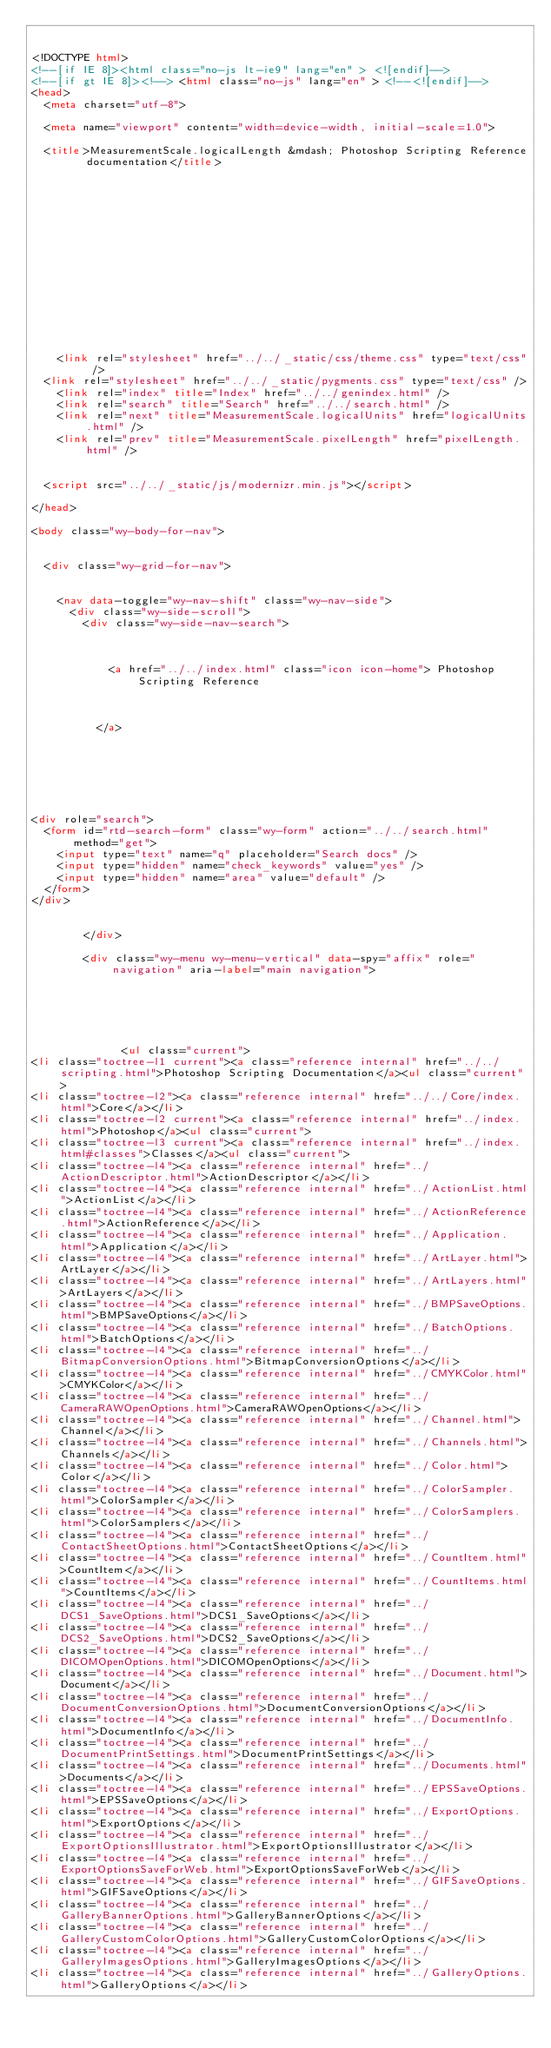Convert code to text. <code><loc_0><loc_0><loc_500><loc_500><_HTML_>

<!DOCTYPE html>
<!--[if IE 8]><html class="no-js lt-ie9" lang="en" > <![endif]-->
<!--[if gt IE 8]><!--> <html class="no-js" lang="en" > <!--<![endif]-->
<head>
  <meta charset="utf-8">
  
  <meta name="viewport" content="width=device-width, initial-scale=1.0">
  
  <title>MeasurementScale.logicalLength &mdash; Photoshop Scripting Reference  documentation</title>
  

  
  
  
  

  

  
  
    

  

  
    <link rel="stylesheet" href="../../_static/css/theme.css" type="text/css" />
  <link rel="stylesheet" href="../../_static/pygments.css" type="text/css" />
    <link rel="index" title="Index" href="../../genindex.html" />
    <link rel="search" title="Search" href="../../search.html" />
    <link rel="next" title="MeasurementScale.logicalUnits" href="logicalUnits.html" />
    <link rel="prev" title="MeasurementScale.pixelLength" href="pixelLength.html" /> 

  
  <script src="../../_static/js/modernizr.min.js"></script>

</head>

<body class="wy-body-for-nav">

   
  <div class="wy-grid-for-nav">

    
    <nav data-toggle="wy-nav-shift" class="wy-nav-side">
      <div class="wy-side-scroll">
        <div class="wy-side-nav-search">
          

          
            <a href="../../index.html" class="icon icon-home"> Photoshop Scripting Reference
          

          
          </a>

          
            
            
          

          
<div role="search">
  <form id="rtd-search-form" class="wy-form" action="../../search.html" method="get">
    <input type="text" name="q" placeholder="Search docs" />
    <input type="hidden" name="check_keywords" value="yes" />
    <input type="hidden" name="area" value="default" />
  </form>
</div>

          
        </div>

        <div class="wy-menu wy-menu-vertical" data-spy="affix" role="navigation" aria-label="main navigation">
          
            
            
              
            
            
              <ul class="current">
<li class="toctree-l1 current"><a class="reference internal" href="../../scripting.html">Photoshop Scripting Documentation</a><ul class="current">
<li class="toctree-l2"><a class="reference internal" href="../../Core/index.html">Core</a></li>
<li class="toctree-l2 current"><a class="reference internal" href="../index.html">Photoshop</a><ul class="current">
<li class="toctree-l3 current"><a class="reference internal" href="../index.html#classes">Classes</a><ul class="current">
<li class="toctree-l4"><a class="reference internal" href="../ActionDescriptor.html">ActionDescriptor</a></li>
<li class="toctree-l4"><a class="reference internal" href="../ActionList.html">ActionList</a></li>
<li class="toctree-l4"><a class="reference internal" href="../ActionReference.html">ActionReference</a></li>
<li class="toctree-l4"><a class="reference internal" href="../Application.html">Application</a></li>
<li class="toctree-l4"><a class="reference internal" href="../ArtLayer.html">ArtLayer</a></li>
<li class="toctree-l4"><a class="reference internal" href="../ArtLayers.html">ArtLayers</a></li>
<li class="toctree-l4"><a class="reference internal" href="../BMPSaveOptions.html">BMPSaveOptions</a></li>
<li class="toctree-l4"><a class="reference internal" href="../BatchOptions.html">BatchOptions</a></li>
<li class="toctree-l4"><a class="reference internal" href="../BitmapConversionOptions.html">BitmapConversionOptions</a></li>
<li class="toctree-l4"><a class="reference internal" href="../CMYKColor.html">CMYKColor</a></li>
<li class="toctree-l4"><a class="reference internal" href="../CameraRAWOpenOptions.html">CameraRAWOpenOptions</a></li>
<li class="toctree-l4"><a class="reference internal" href="../Channel.html">Channel</a></li>
<li class="toctree-l4"><a class="reference internal" href="../Channels.html">Channels</a></li>
<li class="toctree-l4"><a class="reference internal" href="../Color.html">Color</a></li>
<li class="toctree-l4"><a class="reference internal" href="../ColorSampler.html">ColorSampler</a></li>
<li class="toctree-l4"><a class="reference internal" href="../ColorSamplers.html">ColorSamplers</a></li>
<li class="toctree-l4"><a class="reference internal" href="../ContactSheetOptions.html">ContactSheetOptions</a></li>
<li class="toctree-l4"><a class="reference internal" href="../CountItem.html">CountItem</a></li>
<li class="toctree-l4"><a class="reference internal" href="../CountItems.html">CountItems</a></li>
<li class="toctree-l4"><a class="reference internal" href="../DCS1_SaveOptions.html">DCS1_SaveOptions</a></li>
<li class="toctree-l4"><a class="reference internal" href="../DCS2_SaveOptions.html">DCS2_SaveOptions</a></li>
<li class="toctree-l4"><a class="reference internal" href="../DICOMOpenOptions.html">DICOMOpenOptions</a></li>
<li class="toctree-l4"><a class="reference internal" href="../Document.html">Document</a></li>
<li class="toctree-l4"><a class="reference internal" href="../DocumentConversionOptions.html">DocumentConversionOptions</a></li>
<li class="toctree-l4"><a class="reference internal" href="../DocumentInfo.html">DocumentInfo</a></li>
<li class="toctree-l4"><a class="reference internal" href="../DocumentPrintSettings.html">DocumentPrintSettings</a></li>
<li class="toctree-l4"><a class="reference internal" href="../Documents.html">Documents</a></li>
<li class="toctree-l4"><a class="reference internal" href="../EPSSaveOptions.html">EPSSaveOptions</a></li>
<li class="toctree-l4"><a class="reference internal" href="../ExportOptions.html">ExportOptions</a></li>
<li class="toctree-l4"><a class="reference internal" href="../ExportOptionsIllustrator.html">ExportOptionsIllustrator</a></li>
<li class="toctree-l4"><a class="reference internal" href="../ExportOptionsSaveForWeb.html">ExportOptionsSaveForWeb</a></li>
<li class="toctree-l4"><a class="reference internal" href="../GIFSaveOptions.html">GIFSaveOptions</a></li>
<li class="toctree-l4"><a class="reference internal" href="../GalleryBannerOptions.html">GalleryBannerOptions</a></li>
<li class="toctree-l4"><a class="reference internal" href="../GalleryCustomColorOptions.html">GalleryCustomColorOptions</a></li>
<li class="toctree-l4"><a class="reference internal" href="../GalleryImagesOptions.html">GalleryImagesOptions</a></li>
<li class="toctree-l4"><a class="reference internal" href="../GalleryOptions.html">GalleryOptions</a></li></code> 